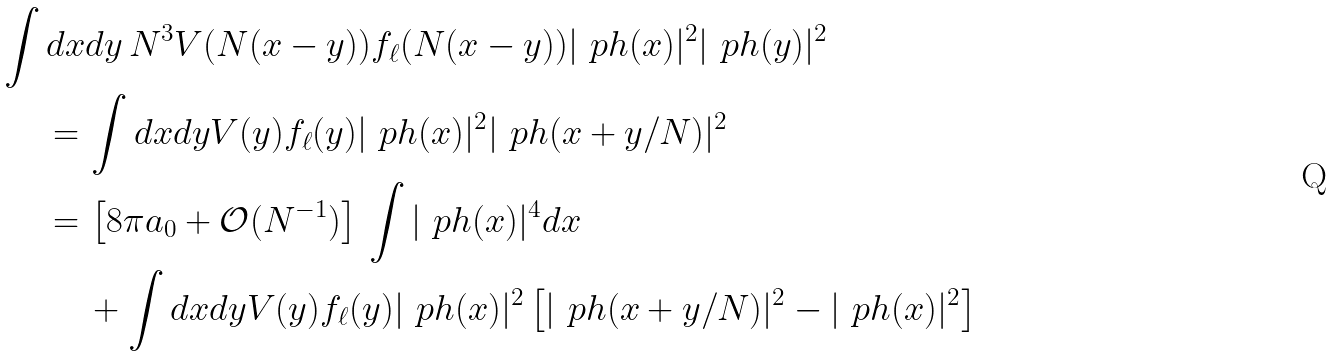Convert formula to latex. <formula><loc_0><loc_0><loc_500><loc_500>\int d x & d y \, N ^ { 3 } V ( N ( x - y ) ) f _ { \ell } ( N ( x - y ) ) | \ p h ( x ) | ^ { 2 } | \ p h ( y ) | ^ { 2 } \\ = \, & \int d x d y V ( y ) f _ { \ell } ( y ) | \ p h ( x ) | ^ { 2 } | \ p h ( x + y / N ) | ^ { 2 } \\ = \, & \left [ 8 \pi a _ { 0 } + \mathcal { O } ( N ^ { - 1 } ) \right ] \, \int | \ p h ( x ) | ^ { 4 } d x \\ & + \int d x d y V ( y ) f _ { \ell } ( y ) | \ p h ( x ) | ^ { 2 } \left [ | \ p h ( x + y / N ) | ^ { 2 } - | \ p h ( x ) | ^ { 2 } \right ]</formula> 